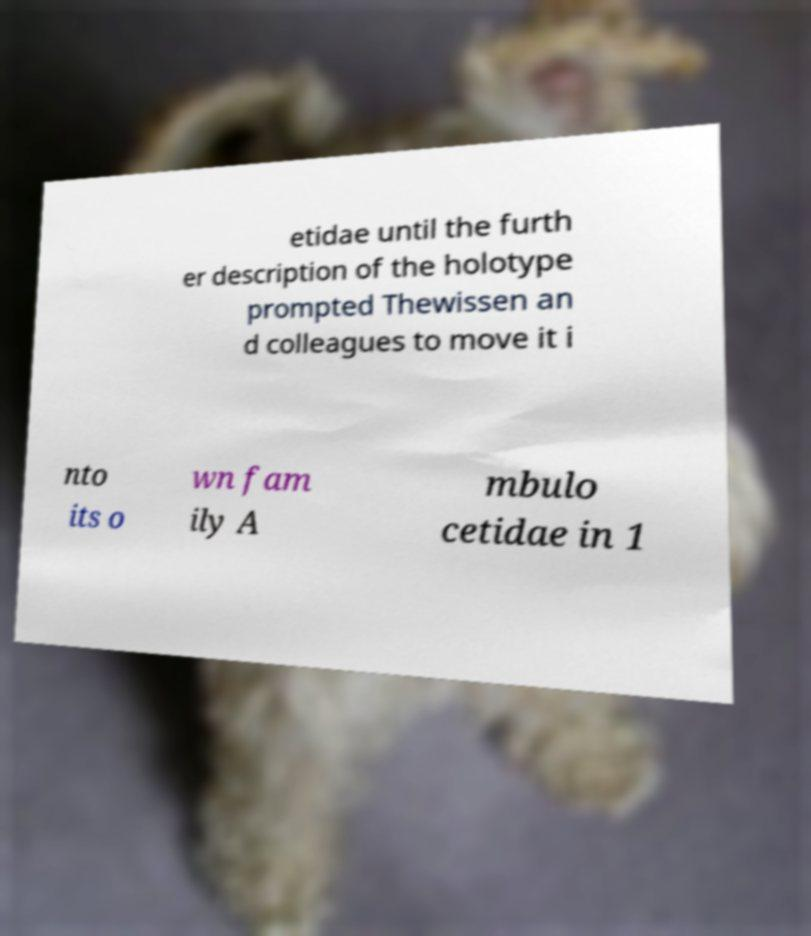Please identify and transcribe the text found in this image. etidae until the furth er description of the holotype prompted Thewissen an d colleagues to move it i nto its o wn fam ily A mbulo cetidae in 1 